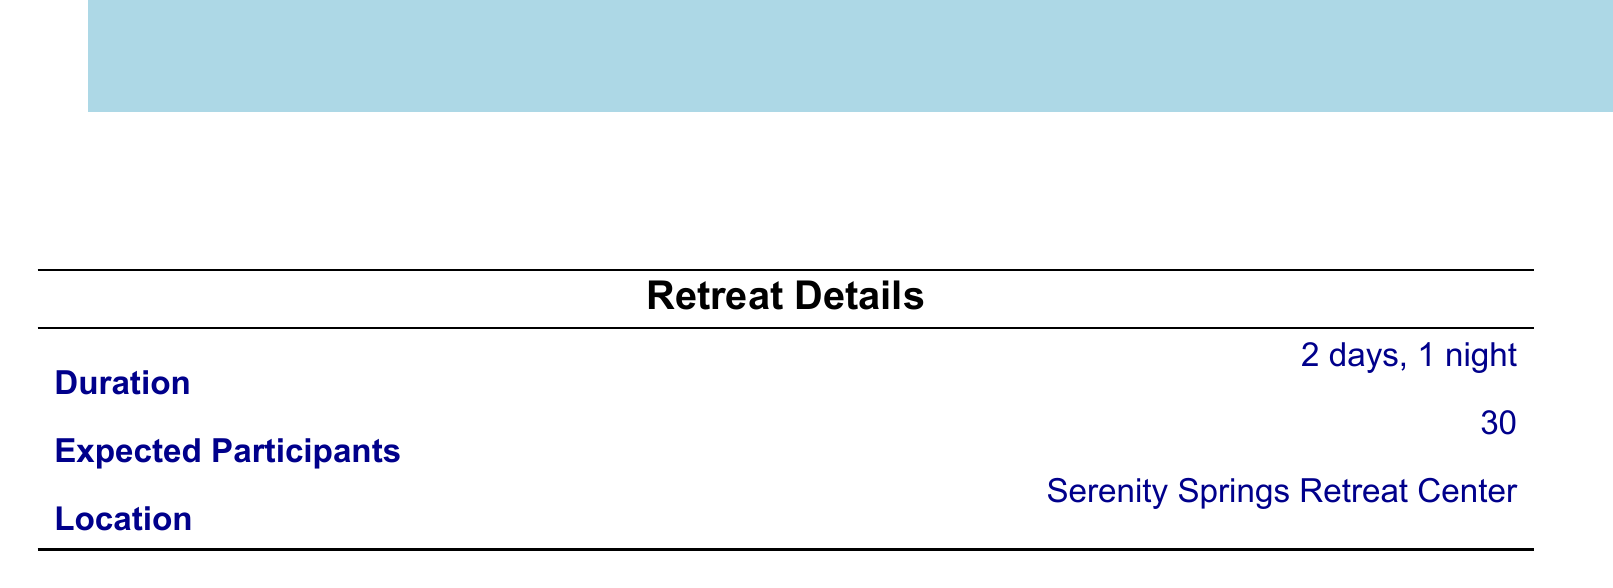what is the total budget? The total budget is listed at the bottom of the budget breakdown section in the document.
Answer: $16,100 how many expected participants are there? The expected participants are stated in the retreat details section as part of planning for the event.
Answer: 30 what is the cost for guest speakers? The total cost for guest speakers is provided in the budget breakdown and consists of their fees.
Answer: $2,700 how much is allocated for participant materials? The budget specifies the allocation for participant materials in the budget breakdown section.
Answer: $1,350 what venue is chosen for the retreat? The venue is mentioned in the details section of the document, outlining the location for the event.
Answer: Serenity Springs Retreat Center how much is budgeted for catering? The budget for catering includes meals and snacks, which can be found in the budget breakdown.
Answer: $3,000 what is the cost for insurance under miscellaneous? A specific cost for insurance is provided in the miscellaneous section of the budget.
Answer: $500 which guest speaker is focused on mindfulness? The guest speakers listed provide their specialties, one of which is mindfulness.
Answer: Dr. Sarah Thompson how much is budgeted for activities? The total cost for activities can be found in the budget breakdown section, summarizing all planned activities.
Answer: $950 how much are yoga mats included in participant materials? The specific amount allocated for yoga mats can be found in the participant materials section.
Answer: $600 